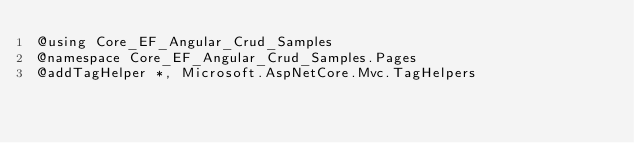<code> <loc_0><loc_0><loc_500><loc_500><_C#_>@using Core_EF_Angular_Crud_Samples
@namespace Core_EF_Angular_Crud_Samples.Pages
@addTagHelper *, Microsoft.AspNetCore.Mvc.TagHelpers
</code> 